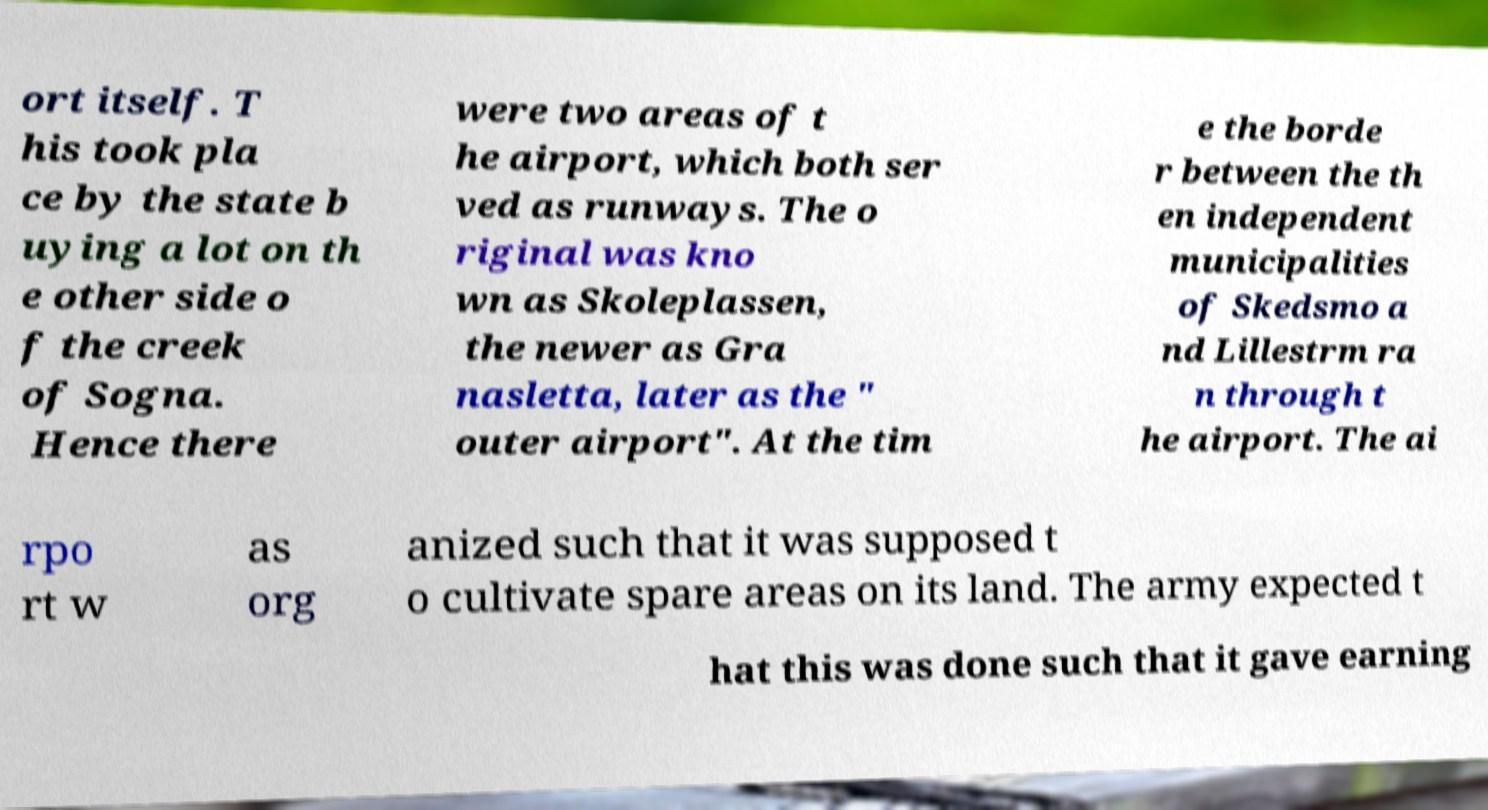Can you accurately transcribe the text from the provided image for me? ort itself. T his took pla ce by the state b uying a lot on th e other side o f the creek of Sogna. Hence there were two areas of t he airport, which both ser ved as runways. The o riginal was kno wn as Skoleplassen, the newer as Gra nasletta, later as the " outer airport". At the tim e the borde r between the th en independent municipalities of Skedsmo a nd Lillestrm ra n through t he airport. The ai rpo rt w as org anized such that it was supposed t o cultivate spare areas on its land. The army expected t hat this was done such that it gave earning 